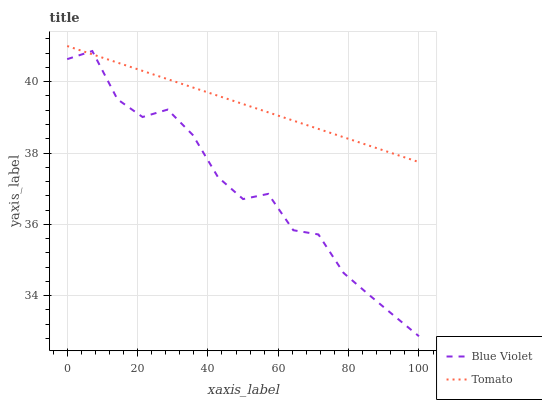Does Blue Violet have the maximum area under the curve?
Answer yes or no. No. Is Blue Violet the smoothest?
Answer yes or no. No. Does Blue Violet have the highest value?
Answer yes or no. No. 